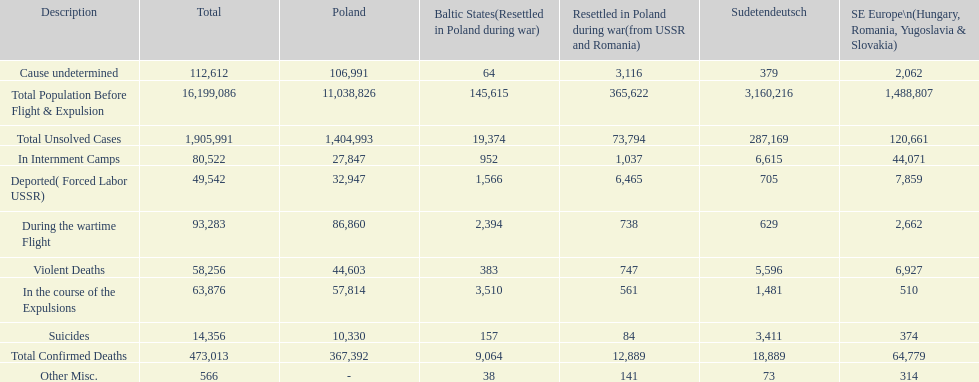What is the total of deaths in internment camps and during the wartime flight? 173,805. 